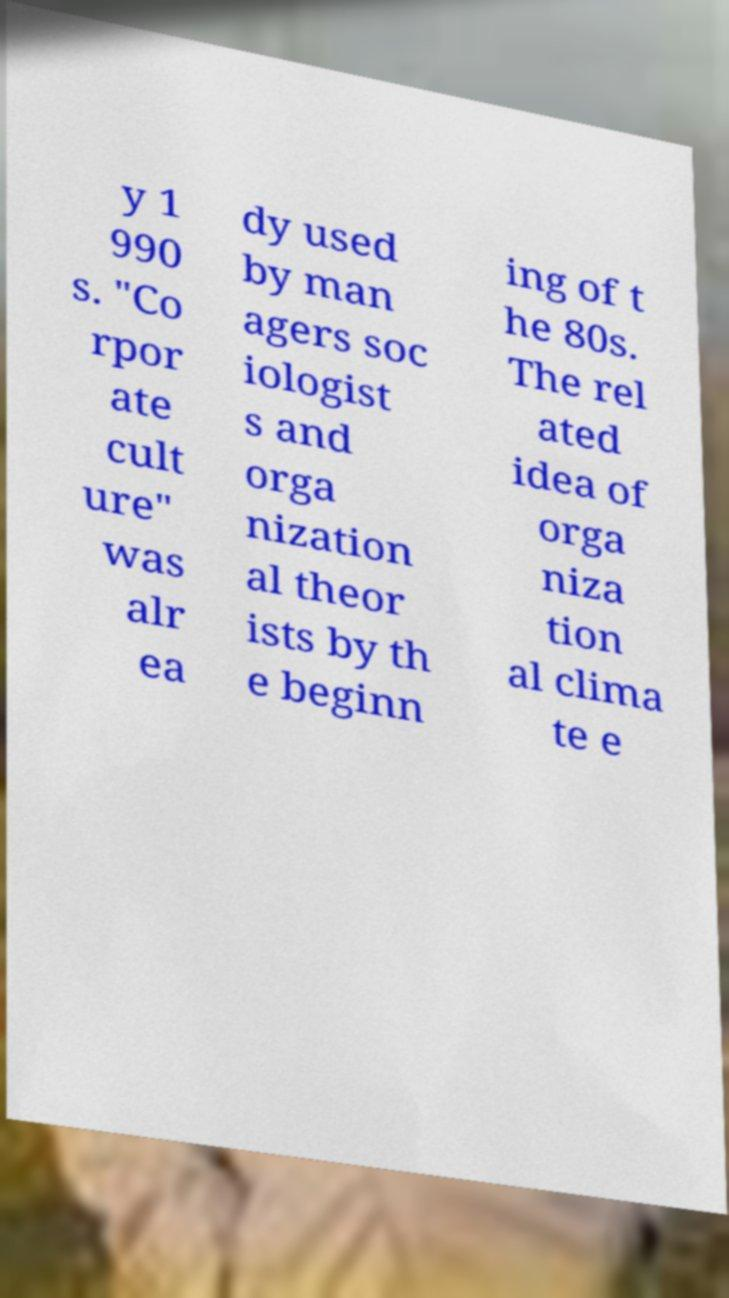Could you assist in decoding the text presented in this image and type it out clearly? y 1 990 s. "Co rpor ate cult ure" was alr ea dy used by man agers soc iologist s and orga nization al theor ists by th e beginn ing of t he 80s. The rel ated idea of orga niza tion al clima te e 